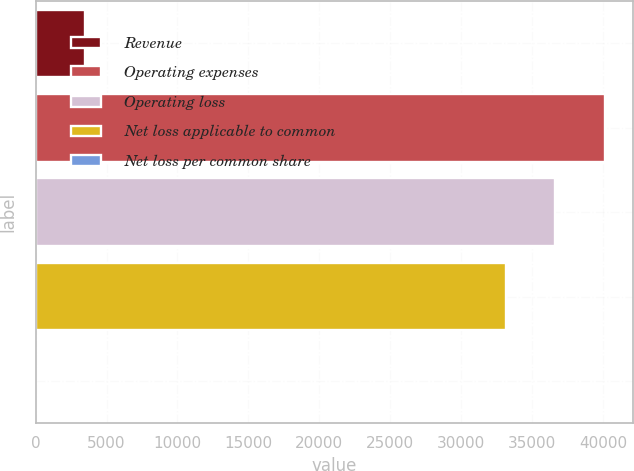<chart> <loc_0><loc_0><loc_500><loc_500><bar_chart><fcel>Revenue<fcel>Operating expenses<fcel>Operating loss<fcel>Net loss applicable to common<fcel>Net loss per common share<nl><fcel>3489.35<fcel>40142.6<fcel>36654.3<fcel>33166<fcel>1.06<nl></chart> 